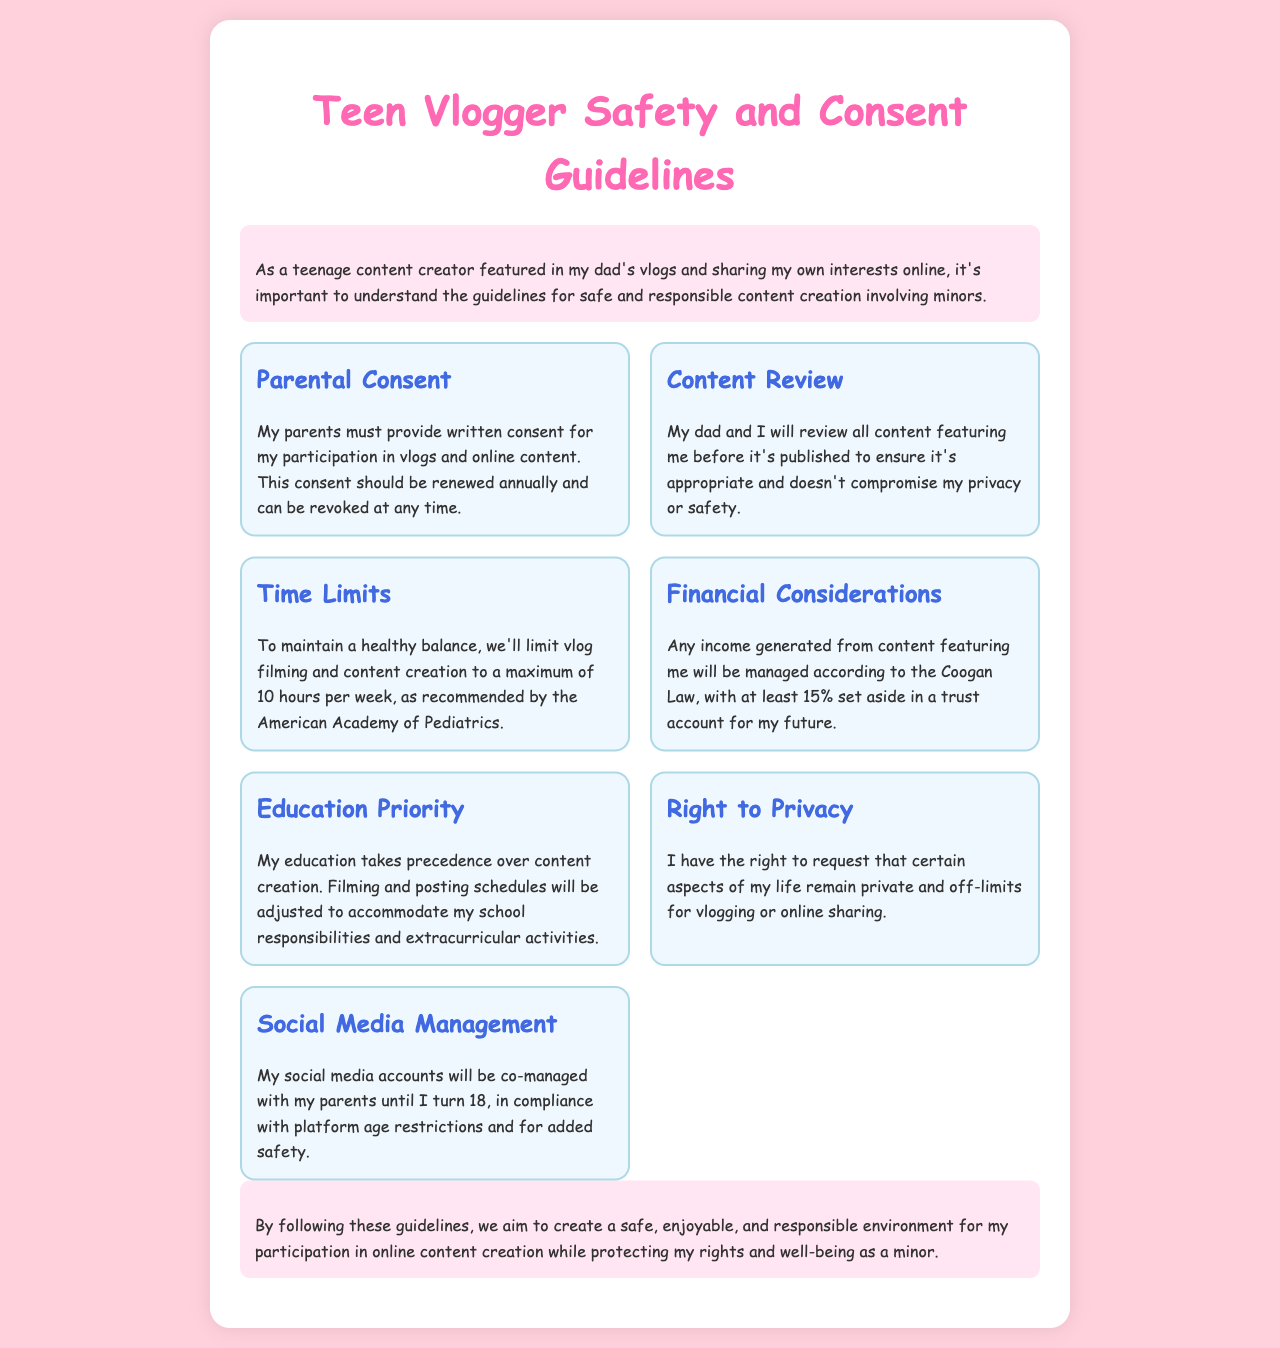What is required for my participation in vlogs? Written consent from parents is necessary for participation in vlogs and online content.
Answer: Written consent How often should consent be renewed? Consent should be renewed annually according to the guidelines.
Answer: Annually What is the maximum filming time recommended per week? The document specifies the maximum filming time as 10 hours per week to maintain balance.
Answer: 10 hours What percentage of income is set aside in a trust account? At least 15% of income generated from content must be set aside in a trust account.
Answer: 15% What takes precedence over content creation? Education takes precedence, as stated in the guidelines.
Answer: Education Who manages my social media accounts until I turn 18? My parents will co-manage my social media accounts until I reach adulthood.
Answer: Parents What should we do before publishing content featuring me? My dad and I need to review all content featuring me before publication.
Answer: Review content What law governs the financial considerations for my content? The Coogan Law applies to the financial management of income derived from my participation.
Answer: Coogan Law What kind of environment do we aim to create through these guidelines? The guidelines aim to create a safe, enjoyable, and responsible environment for content creation.
Answer: Safe and responsible environment 